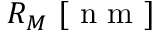<formula> <loc_0><loc_0><loc_500><loc_500>R _ { M } \ [ n m ]</formula> 